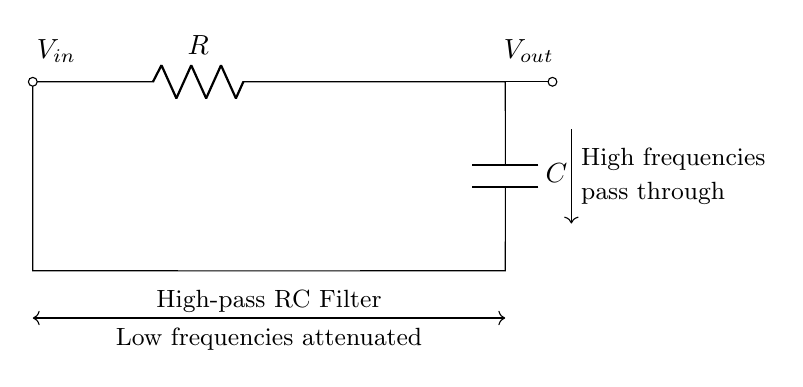What are the components in this circuit? The circuit contains a resistor (R) and a capacitor (C). These are the two primary components in a high-pass RC filter.
Answer: Resistor and capacitor What type of filter is represented in this circuit? The diagram shows a high-pass filter, which allows high frequencies to pass and attenuates low frequencies. This is indicated by the label stating "High-pass RC Filter."
Answer: High-pass filter What is the purpose of the capacitor in this circuit? The capacitor in a high-pass filter blocks low-frequency signals while allowing high-frequency signals to pass through. This is captured in the functional description of the circuit.
Answer: Blocks low frequencies What does the output voltage represent in this circuit? The output voltage is denoted as V out and represents the voltage across the capacitor, which reflects the high-frequency components present in the input signal.
Answer: Voltage across capacitor What happens to low frequencies in this circuit? Low frequencies are attenuated, meaning their amplitude is reduced significantly as they cannot pass through the circuit as effectively as high frequencies. This behavior is specifically mentioned in the diagram features.
Answer: Attenuated What is the expected result when high-frequency signals are applied? High-frequency signals will pass through the circuit with little to no attenuation, allowing them to reach the output, as indicated by the description on the circuit diagram.
Answer: Pass through What does the arrow signify in this circuit diagram? The arrow indicates the direction of current flow or signal transmission from the input to the output, illustrating the circuit's function as a filter that selectively allows certain frequencies through.
Answer: Direction of current flow 